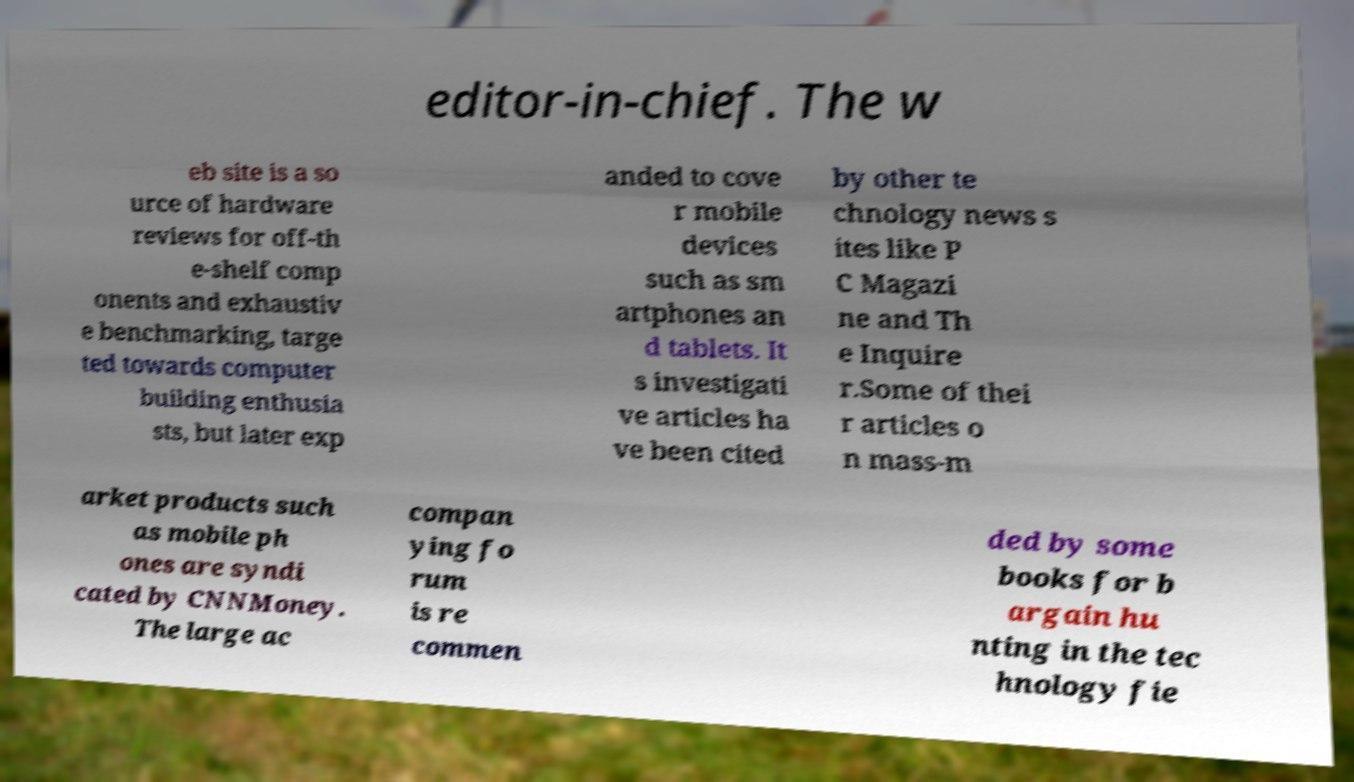I need the written content from this picture converted into text. Can you do that? editor-in-chief. The w eb site is a so urce of hardware reviews for off-th e-shelf comp onents and exhaustiv e benchmarking, targe ted towards computer building enthusia sts, but later exp anded to cove r mobile devices such as sm artphones an d tablets. It s investigati ve articles ha ve been cited by other te chnology news s ites like P C Magazi ne and Th e Inquire r.Some of thei r articles o n mass-m arket products such as mobile ph ones are syndi cated by CNNMoney. The large ac compan ying fo rum is re commen ded by some books for b argain hu nting in the tec hnology fie 